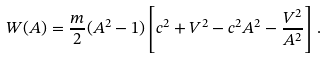Convert formula to latex. <formula><loc_0><loc_0><loc_500><loc_500>W ( A ) = \frac { m } { 2 } ( A ^ { 2 } - 1 ) \left [ c ^ { 2 } + V ^ { 2 } - c ^ { 2 } A ^ { 2 } - \frac { V ^ { 2 } } { A ^ { 2 } } \right ] \, .</formula> 